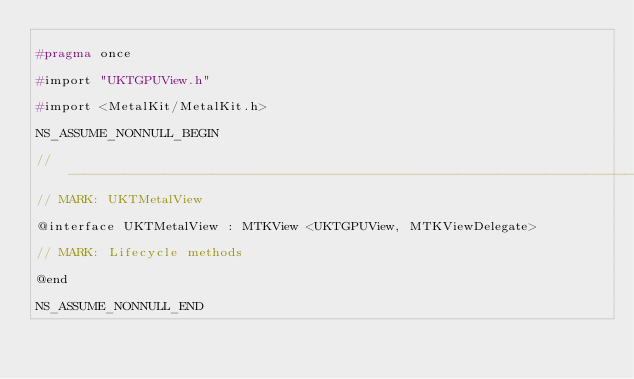Convert code to text. <code><loc_0><loc_0><loc_500><loc_500><_C_>
#pragma once

#import "UKTGPUView.h"

#import <MetalKit/MetalKit.h>

NS_ASSUME_NONNULL_BEGIN

//----------------------------------------------------------------------------------------------------------------------
// MARK: UKTMetalView

@interface UKTMetalView : MTKView <UKTGPUView, MTKViewDelegate>

// MARK: Lifecycle methods

@end

NS_ASSUME_NONNULL_END
</code> 